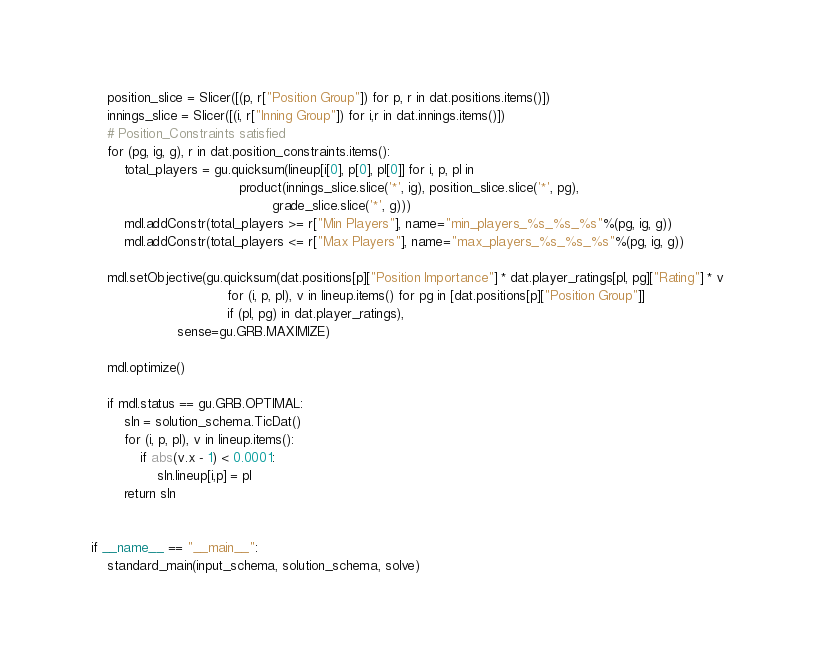Convert code to text. <code><loc_0><loc_0><loc_500><loc_500><_Python_>    position_slice = Slicer([(p, r["Position Group"]) for p, r in dat.positions.items()])
    innings_slice = Slicer([(i, r["Inning Group"]) for i,r in dat.innings.items()])
    # Position_Constraints satisfied
    for (pg, ig, g), r in dat.position_constraints.items():
        total_players = gu.quicksum(lineup[i[0], p[0], pl[0]] for i, p, pl in
                                    product(innings_slice.slice('*', ig), position_slice.slice('*', pg),
                                            grade_slice.slice('*', g)))
        mdl.addConstr(total_players >= r["Min Players"], name="min_players_%s_%s_%s"%(pg, ig, g))
        mdl.addConstr(total_players <= r["Max Players"], name="max_players_%s_%s_%s"%(pg, ig, g))

    mdl.setObjective(gu.quicksum(dat.positions[p]["Position Importance"] * dat.player_ratings[pl, pg]["Rating"] * v
                                 for (i, p, pl), v in lineup.items() for pg in [dat.positions[p]["Position Group"]]
                                 if (pl, pg) in dat.player_ratings),
                     sense=gu.GRB.MAXIMIZE)

    mdl.optimize()

    if mdl.status == gu.GRB.OPTIMAL:
        sln = solution_schema.TicDat()
        for (i, p, pl), v in lineup.items():
            if abs(v.x - 1) < 0.0001:
                sln.lineup[i,p] = pl
        return sln


if __name__ == "__main__":
    standard_main(input_schema, solution_schema, solve)
</code> 